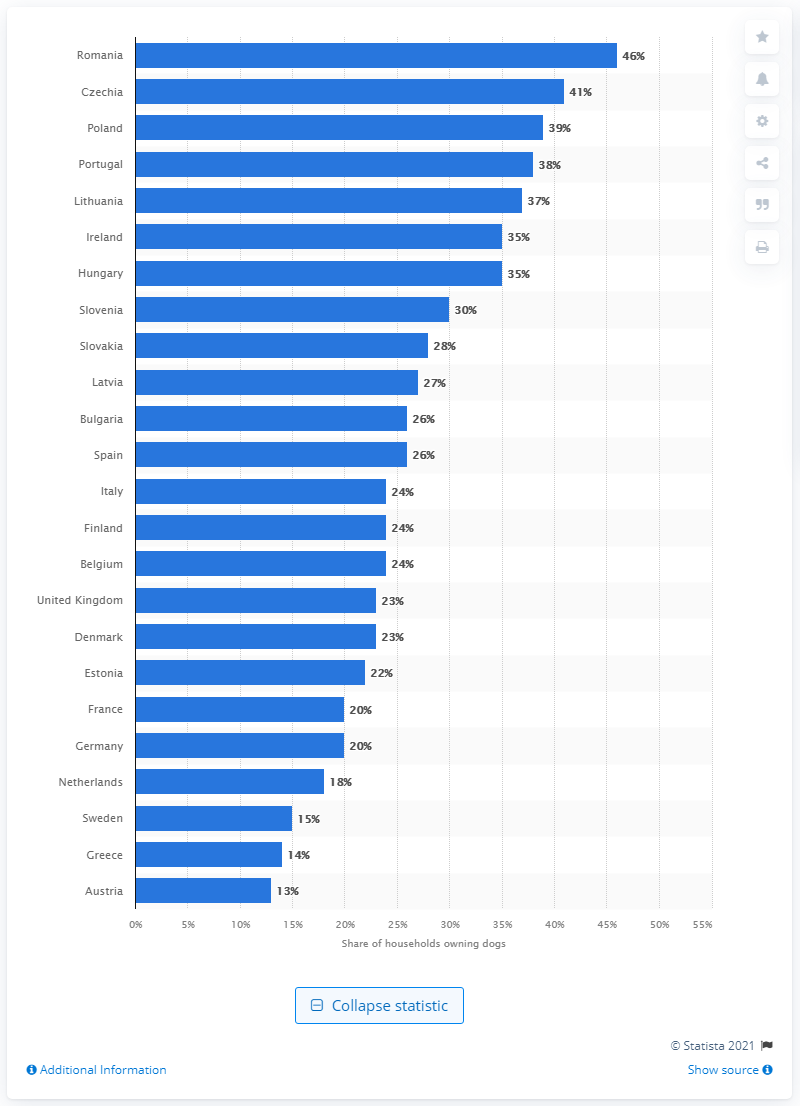List a handful of essential elements in this visual. In the European Union, Romania had the highest percentage of dog-owning households. 